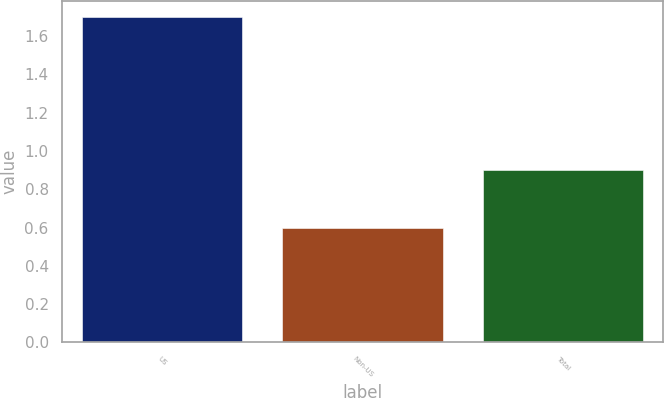Convert chart. <chart><loc_0><loc_0><loc_500><loc_500><bar_chart><fcel>US<fcel>Non-US<fcel>Total<nl><fcel>1.7<fcel>0.6<fcel>0.9<nl></chart> 